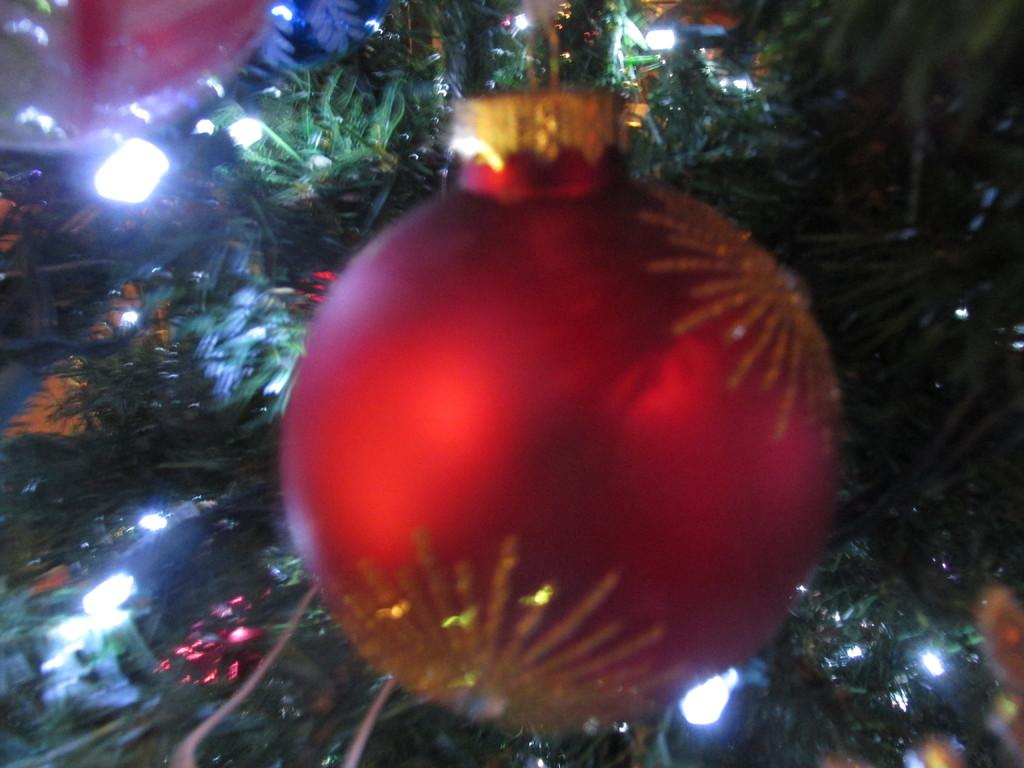What type of tree is in the image? There is a Christmas tree in the image. What feature of the Christmas tree is mentioned in the facts? The Christmas tree has lights. What type of decorations are hanging from the Christmas tree? Decoration balls are hanging from the Christmas tree. What shape is the bath in the image? There is no bath present in the image; it features a Christmas tree with lights and decoration balls. 